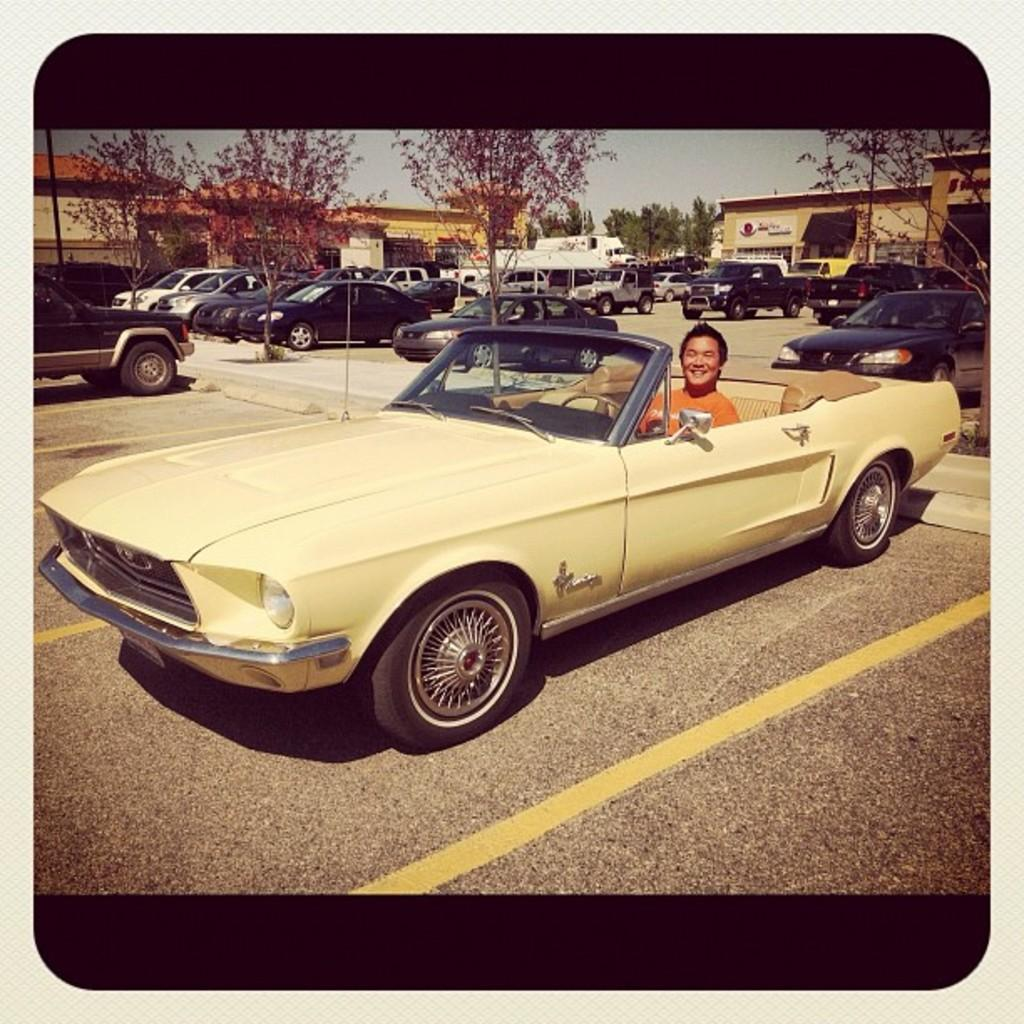What is the man in the image doing? The man is sitting inside a car. What is the man's facial expression in the image? The man is smiling. What can be seen in the background of the image? There are cars parked on the road, buildings, trees, and the sky visible in the background of the image. What type of oil can be seen dripping from the trees in the image? There is no oil visible in the image, and the trees are not depicted as dripping anything. 